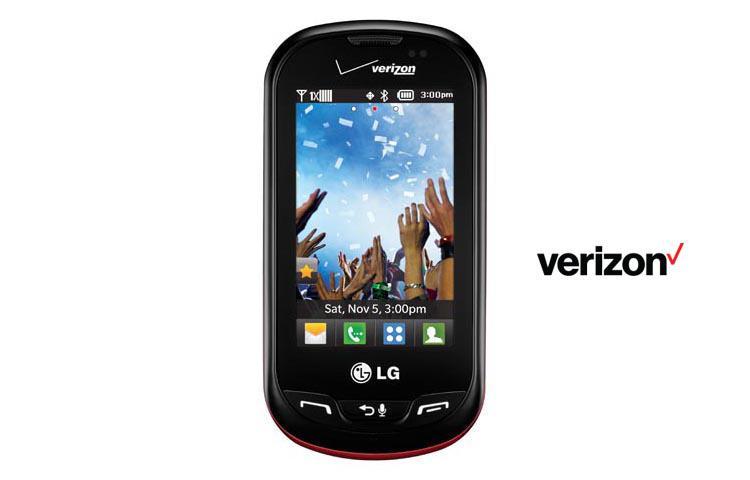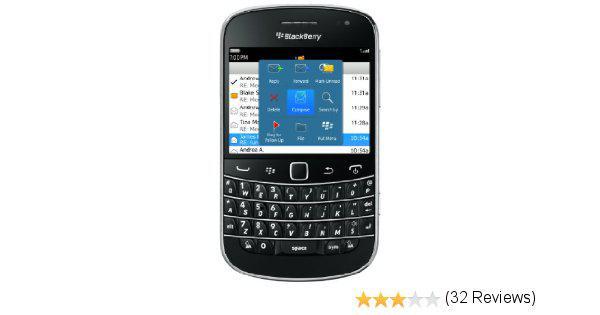The first image is the image on the left, the second image is the image on the right. Assess this claim about the two images: "There are a number of stars to the bottom right of one of the phones.". Correct or not? Answer yes or no. Yes. The first image is the image on the left, the second image is the image on the right. Given the left and right images, does the statement "Both phones display the same time." hold true? Answer yes or no. No. 